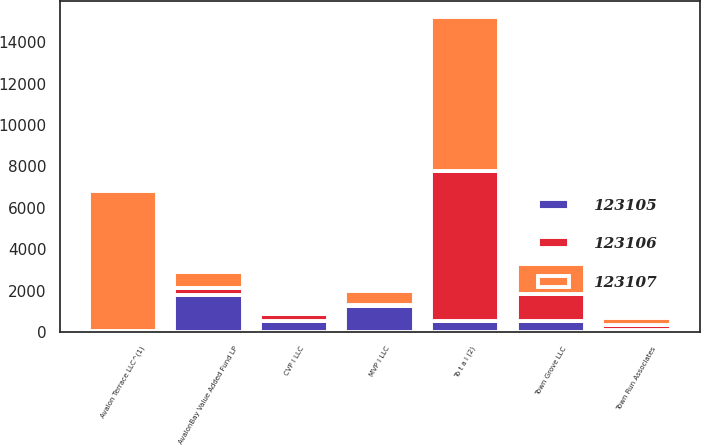<chart> <loc_0><loc_0><loc_500><loc_500><stacked_bar_chart><ecel><fcel>Town Grove LLC<fcel>CVP I LLC<fcel>Town Run Associates<fcel>Avalon Terrace LLC^(1)<fcel>MVP I LLC<fcel>AvalonBay Value Added Fund LP<fcel>To t a l (2)<nl><fcel>123105<fcel>567<fcel>567<fcel>107<fcel>22<fcel>1261<fcel>1775<fcel>567<nl><fcel>123107<fcel>1457<fcel>68<fcel>298<fcel>6736<fcel>662<fcel>799<fcel>7455<nl><fcel>123106<fcel>1286<fcel>339<fcel>266<fcel>58<fcel>57<fcel>341<fcel>7198<nl></chart> 